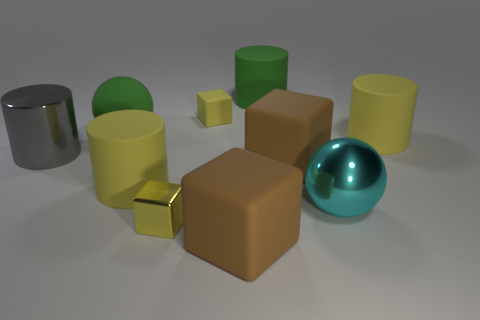Subtract all brown balls. Subtract all gray cylinders. How many balls are left? 2 Subtract all balls. How many objects are left? 8 Subtract 1 cyan balls. How many objects are left? 9 Subtract all big purple spheres. Subtract all large green balls. How many objects are left? 9 Add 8 shiny spheres. How many shiny spheres are left? 9 Add 2 big rubber things. How many big rubber things exist? 8 